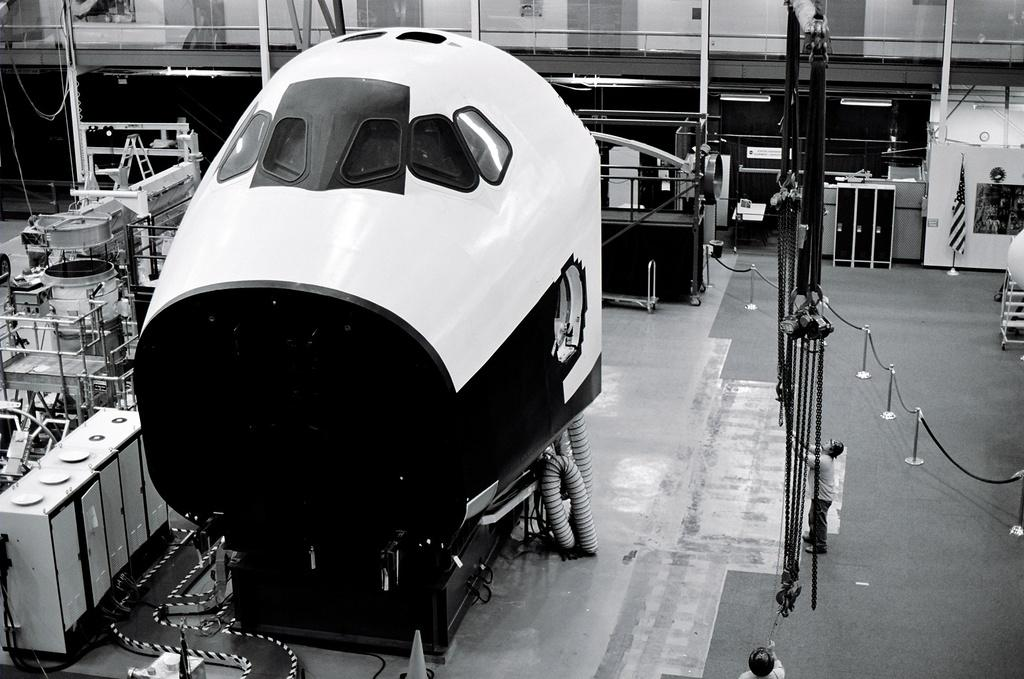What is the main object in the center of the image? There is an electronic machine in the center of the image. What can be seen in the background of the image? In the background of the image, there are tools, tables, poles, fences, a flag, and a person standing. Can you describe the other objects in the background of the image? There are a few other objects in the background of the image, but their specific details are not mentioned in the provided facts. What type of comfort does the creator of the electronic machine experience while using it? There is no information about the creator of the electronic machine or their experience of comfort while using it in the image. 